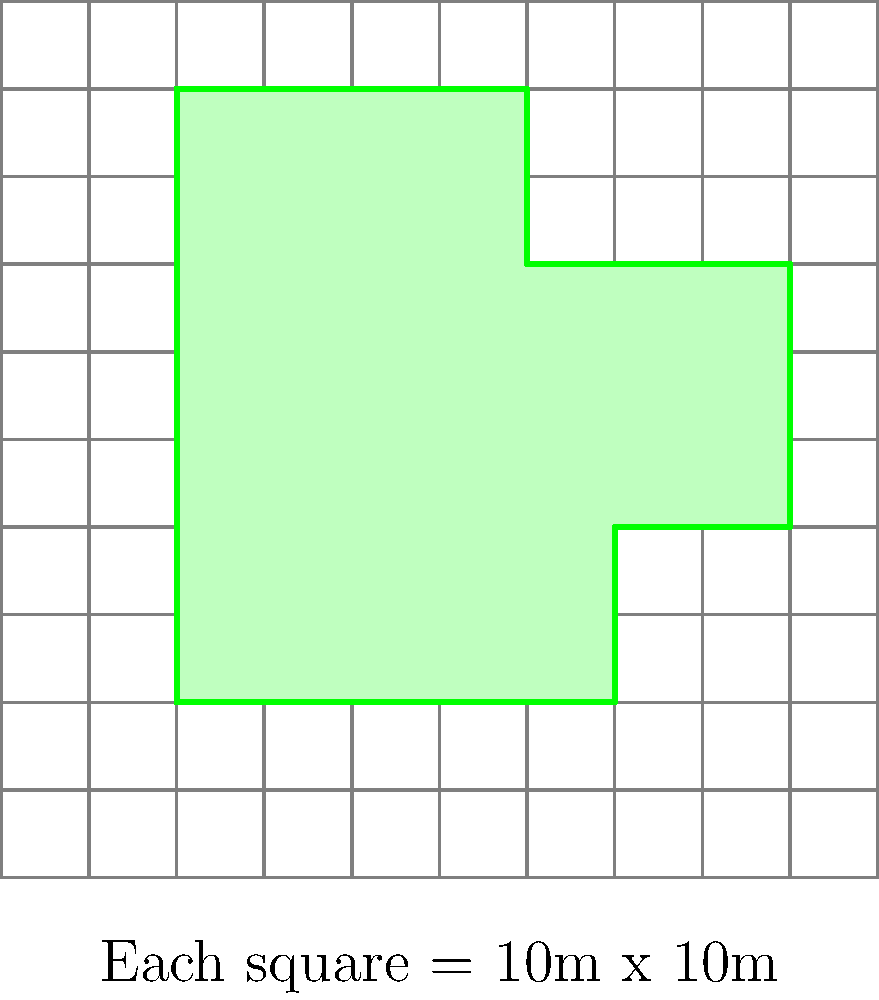The image shows an irregularly shaped park on a grid system. Each square on the grid represents an area of 10 meters by 10 meters. What is the perimeter of the park in meters? Let's break this down step-by-step:

1. We need to count the number of grid lines the park's border crosses.

2. Starting from the bottom-left corner and moving clockwise:
   - Bottom edge: 5 units
   - Right edge (first part): 2 units
   - Right edge (second part): 3 units
   - Top edge (right part): 2 units
   - Left edge (top part): 3 units
   - Left edge (bottom part): 2 units

3. Adding these up: $5 + 2 + 3 + 2 + 3 + 2 = 17$ units

4. Each unit on the grid represents 10 meters.

5. To get the total perimeter in meters, we multiply the number of units by 10:
   $17 \times 10 = 170$ meters

Therefore, the perimeter of the park is 170 meters.
Answer: 170 meters 